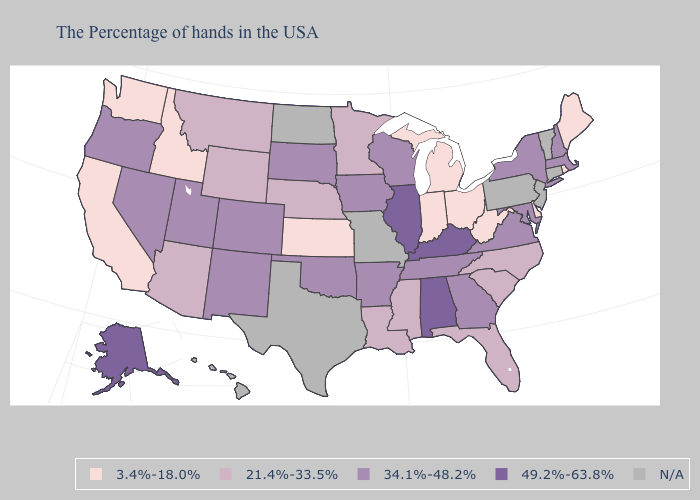Name the states that have a value in the range N/A?
Be succinct. Vermont, Connecticut, New Jersey, Pennsylvania, Missouri, Texas, North Dakota, Hawaii. Which states have the lowest value in the Northeast?
Give a very brief answer. Maine, Rhode Island. Which states have the lowest value in the South?
Give a very brief answer. Delaware, West Virginia. Name the states that have a value in the range 3.4%-18.0%?
Concise answer only. Maine, Rhode Island, Delaware, West Virginia, Ohio, Michigan, Indiana, Kansas, Idaho, California, Washington. Name the states that have a value in the range 34.1%-48.2%?
Short answer required. Massachusetts, New Hampshire, New York, Maryland, Virginia, Georgia, Tennessee, Wisconsin, Arkansas, Iowa, Oklahoma, South Dakota, Colorado, New Mexico, Utah, Nevada, Oregon. What is the lowest value in states that border New Jersey?
Quick response, please. 3.4%-18.0%. Name the states that have a value in the range 49.2%-63.8%?
Keep it brief. Kentucky, Alabama, Illinois, Alaska. How many symbols are there in the legend?
Short answer required. 5. Among the states that border Rhode Island , which have the highest value?
Be succinct. Massachusetts. What is the lowest value in states that border Wyoming?
Quick response, please. 3.4%-18.0%. Name the states that have a value in the range 49.2%-63.8%?
Quick response, please. Kentucky, Alabama, Illinois, Alaska. Does Massachusetts have the highest value in the Northeast?
Give a very brief answer. Yes. What is the value of Idaho?
Short answer required. 3.4%-18.0%. Which states hav the highest value in the West?
Be succinct. Alaska. 